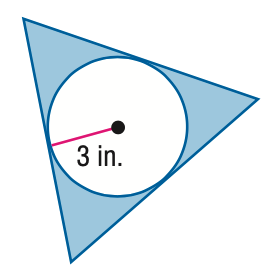Answer the mathemtical geometry problem and directly provide the correct option letter.
Question: Find the area of the shaded region. Assume that all polygons that appear to be regular are regular. Round to the nearest tenth.
Choices: A: 18.5 B: 46.8 C: 52.7 D: 65.3 A 